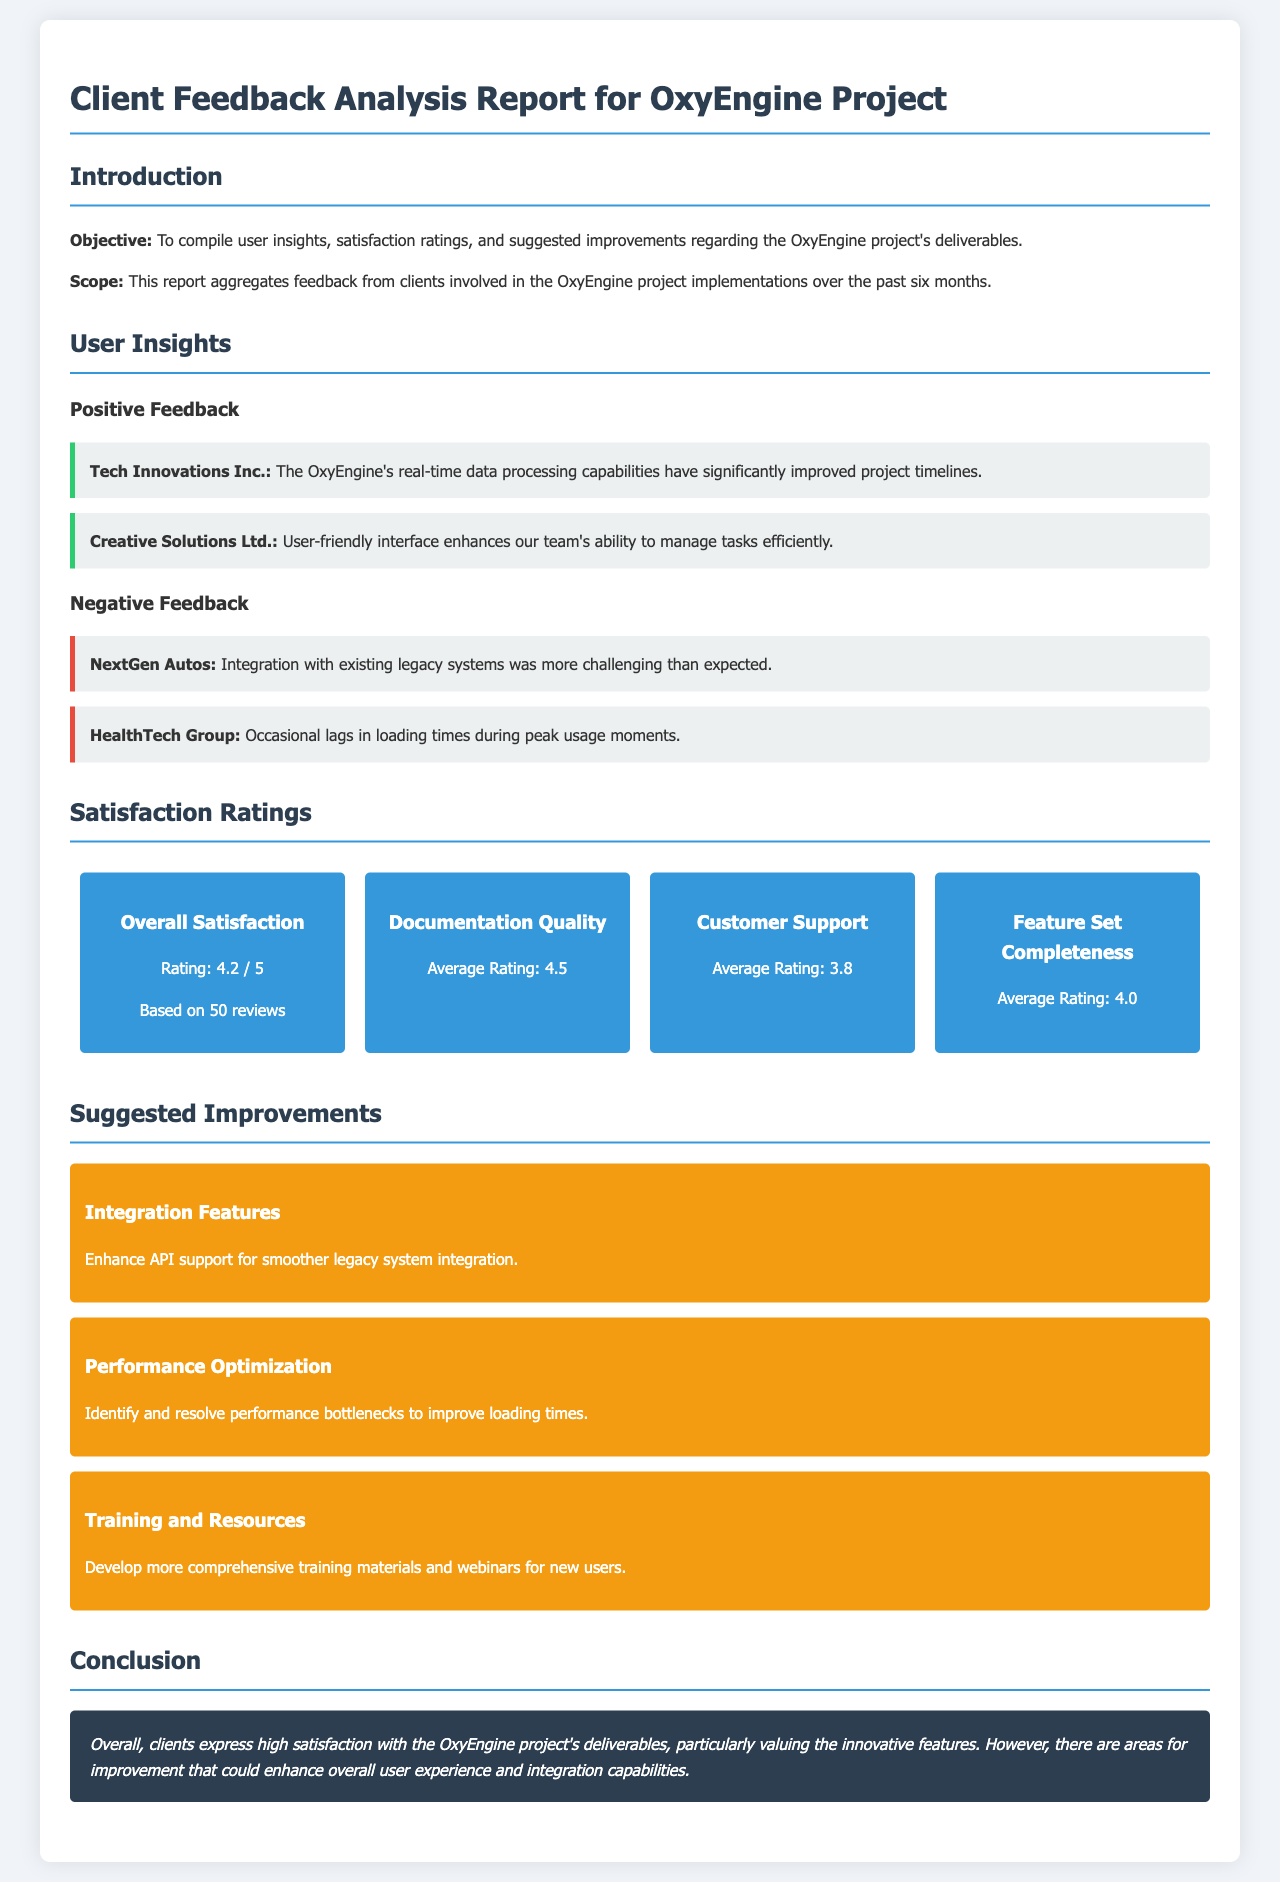What is the overall satisfaction rating? The overall satisfaction rating is found in the satisfaction ratings section, where it states "Rating: 4.2 / 5".
Answer: 4.2 / 5 Who rated the user-friendly interface positively? The positive feedback section mentions "Creative Solutions Ltd." specifically praising the user-friendly interface.
Answer: Creative Solutions Ltd What is the average rating for customer support? The rating for customer support is provided in the ratings section and states "Average Rating: 3.8".
Answer: 3.8 Which company experienced challenges with integration? In the negative feedback section, "NextGen Autos" mentioned challenges with integration with legacy systems.
Answer: NextGen Autos What is one suggested improvement related to performance? The suggested improvements section mentions "Identify and resolve performance bottlenecks to improve loading times" as a performance-related improvement.
Answer: Performance Optimization How many reviews contributed to the overall satisfaction rating? The overall satisfaction rating section states it is based on "50 reviews".
Answer: 50 reviews What color indicates negative feedback in the document? The section containing negative feedback uses a specific background color identified in styling, which is represented with a border left color.
Answer: Red What is the title of the report? The title is stated at the top of the document as “Client Feedback Analysis Report for OxyEngine Project”.
Answer: Client Feedback Analysis Report for OxyEngine Project 